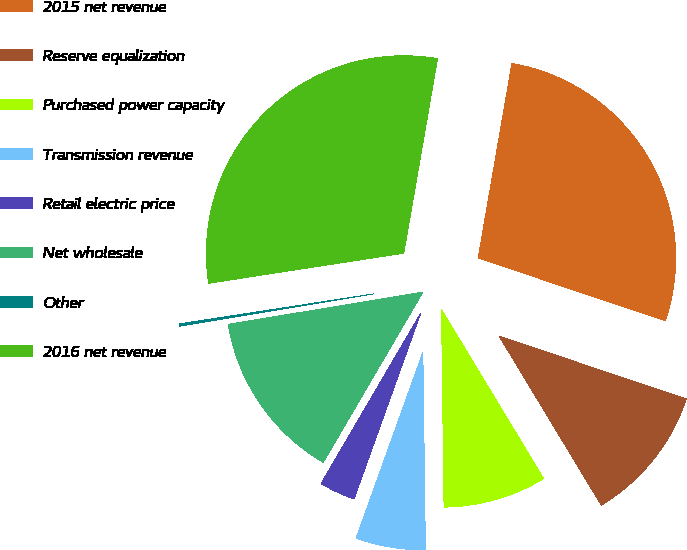Convert chart. <chart><loc_0><loc_0><loc_500><loc_500><pie_chart><fcel>2015 net revenue<fcel>Reserve equalization<fcel>Purchased power capacity<fcel>Transmission revenue<fcel>Retail electric price<fcel>Net wholesale<fcel>Other<fcel>2016 net revenue<nl><fcel>27.42%<fcel>11.2%<fcel>8.45%<fcel>5.69%<fcel>2.94%<fcel>13.95%<fcel>0.19%<fcel>30.17%<nl></chart> 